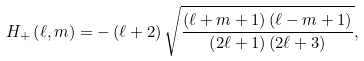Convert formula to latex. <formula><loc_0><loc_0><loc_500><loc_500>H _ { + } \left ( \ell , m \right ) = - \left ( \ell + 2 \right ) \sqrt { \frac { \left ( \ell + m + 1 \right ) \left ( \ell - m + 1 \right ) } { \left ( 2 \ell + 1 \right ) \left ( 2 \ell + 3 \right ) } } ,</formula> 